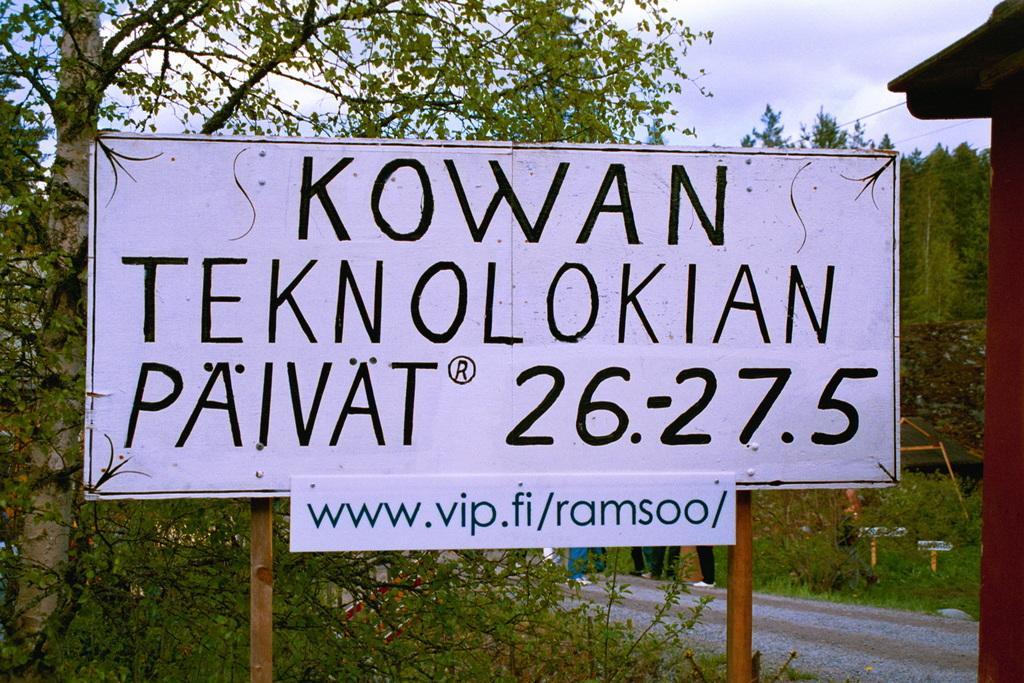Please provide a concise description of this image. In this image we can see a board with some text and there are some plants and trees and in the background, we can see a few people are standing. At the top we can see the sky. 